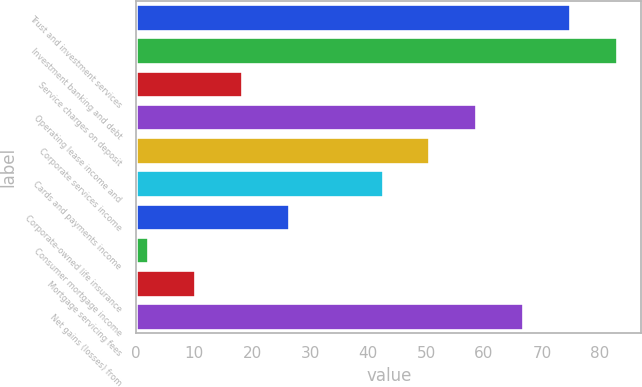Convert chart. <chart><loc_0><loc_0><loc_500><loc_500><bar_chart><fcel>Trust and investment services<fcel>Investment banking and debt<fcel>Service charges on deposit<fcel>Operating lease income and<fcel>Corporate services income<fcel>Cards and payments income<fcel>Corporate-owned life insurance<fcel>Consumer mortgage income<fcel>Mortgage servicing fees<fcel>Net gains (losses) from<nl><fcel>74.9<fcel>83<fcel>18.2<fcel>58.7<fcel>50.6<fcel>42.5<fcel>26.3<fcel>2<fcel>10.1<fcel>66.8<nl></chart> 